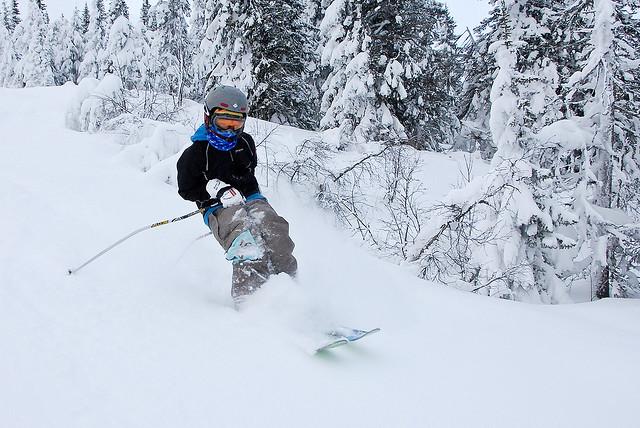What are the colors on the boys gloves?
Give a very brief answer. White. What season is this?
Short answer required. Winter. What is the man doing?
Quick response, please. Skiing. What is this person doing?
Give a very brief answer. Skiing. 